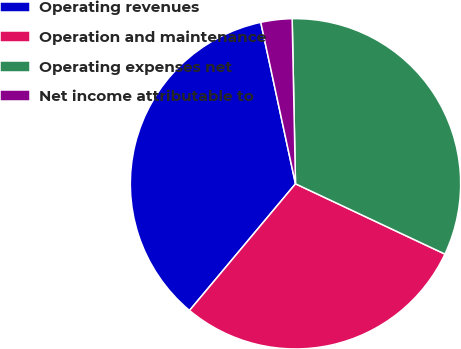<chart> <loc_0><loc_0><loc_500><loc_500><pie_chart><fcel>Operating revenues<fcel>Operation and maintenance<fcel>Operating expenses net<fcel>Net income attributable to<nl><fcel>35.54%<fcel>29.09%<fcel>32.32%<fcel>3.05%<nl></chart> 